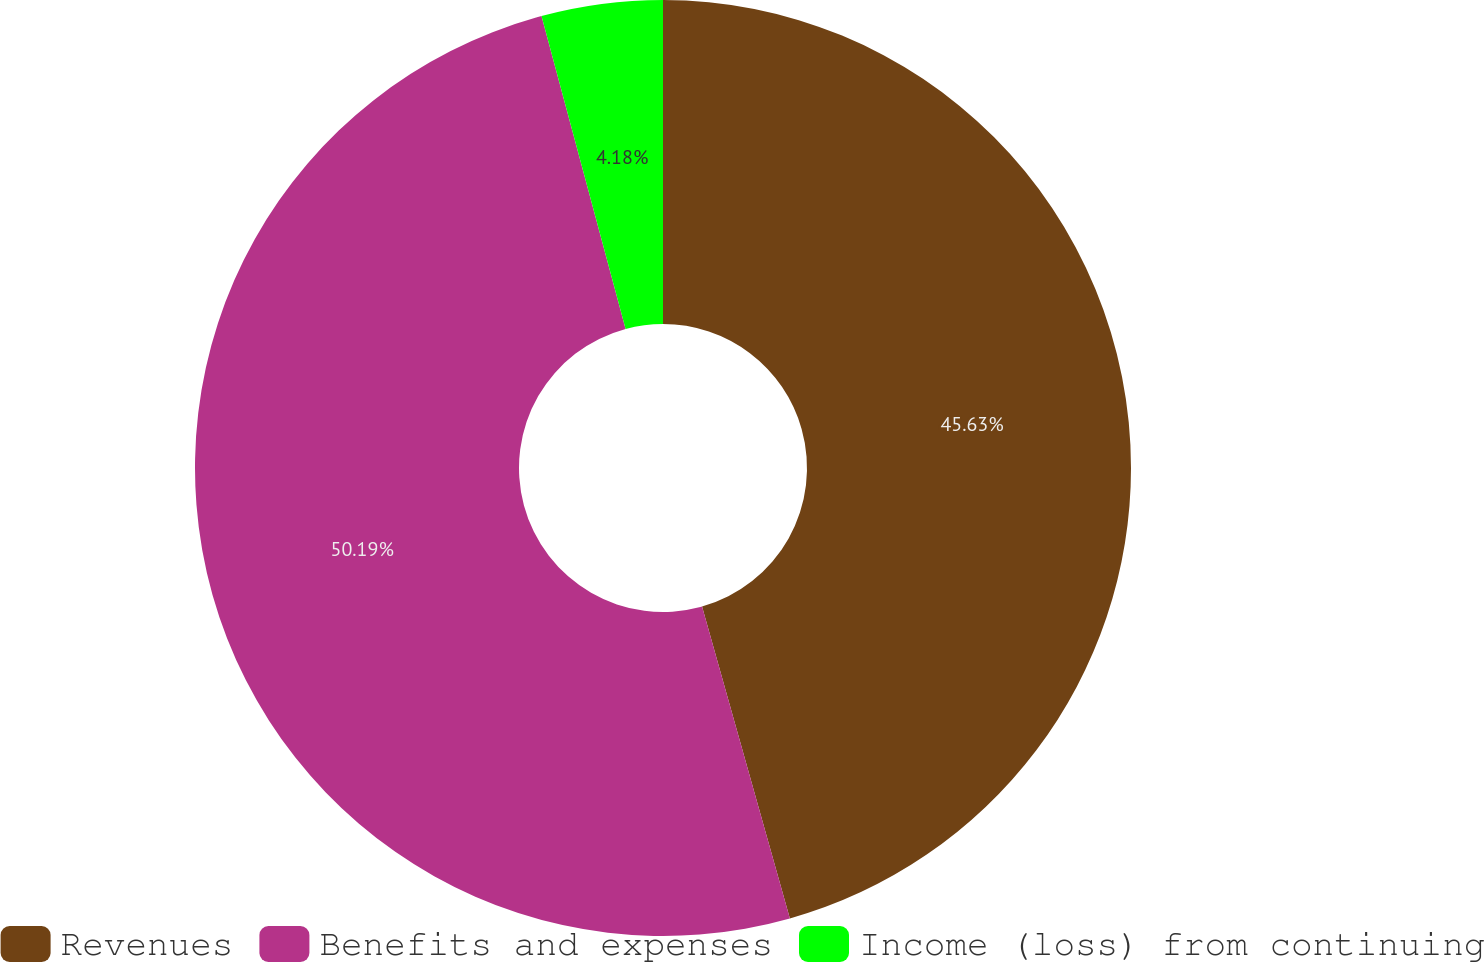Convert chart. <chart><loc_0><loc_0><loc_500><loc_500><pie_chart><fcel>Revenues<fcel>Benefits and expenses<fcel>Income (loss) from continuing<nl><fcel>45.63%<fcel>50.19%<fcel>4.18%<nl></chart> 